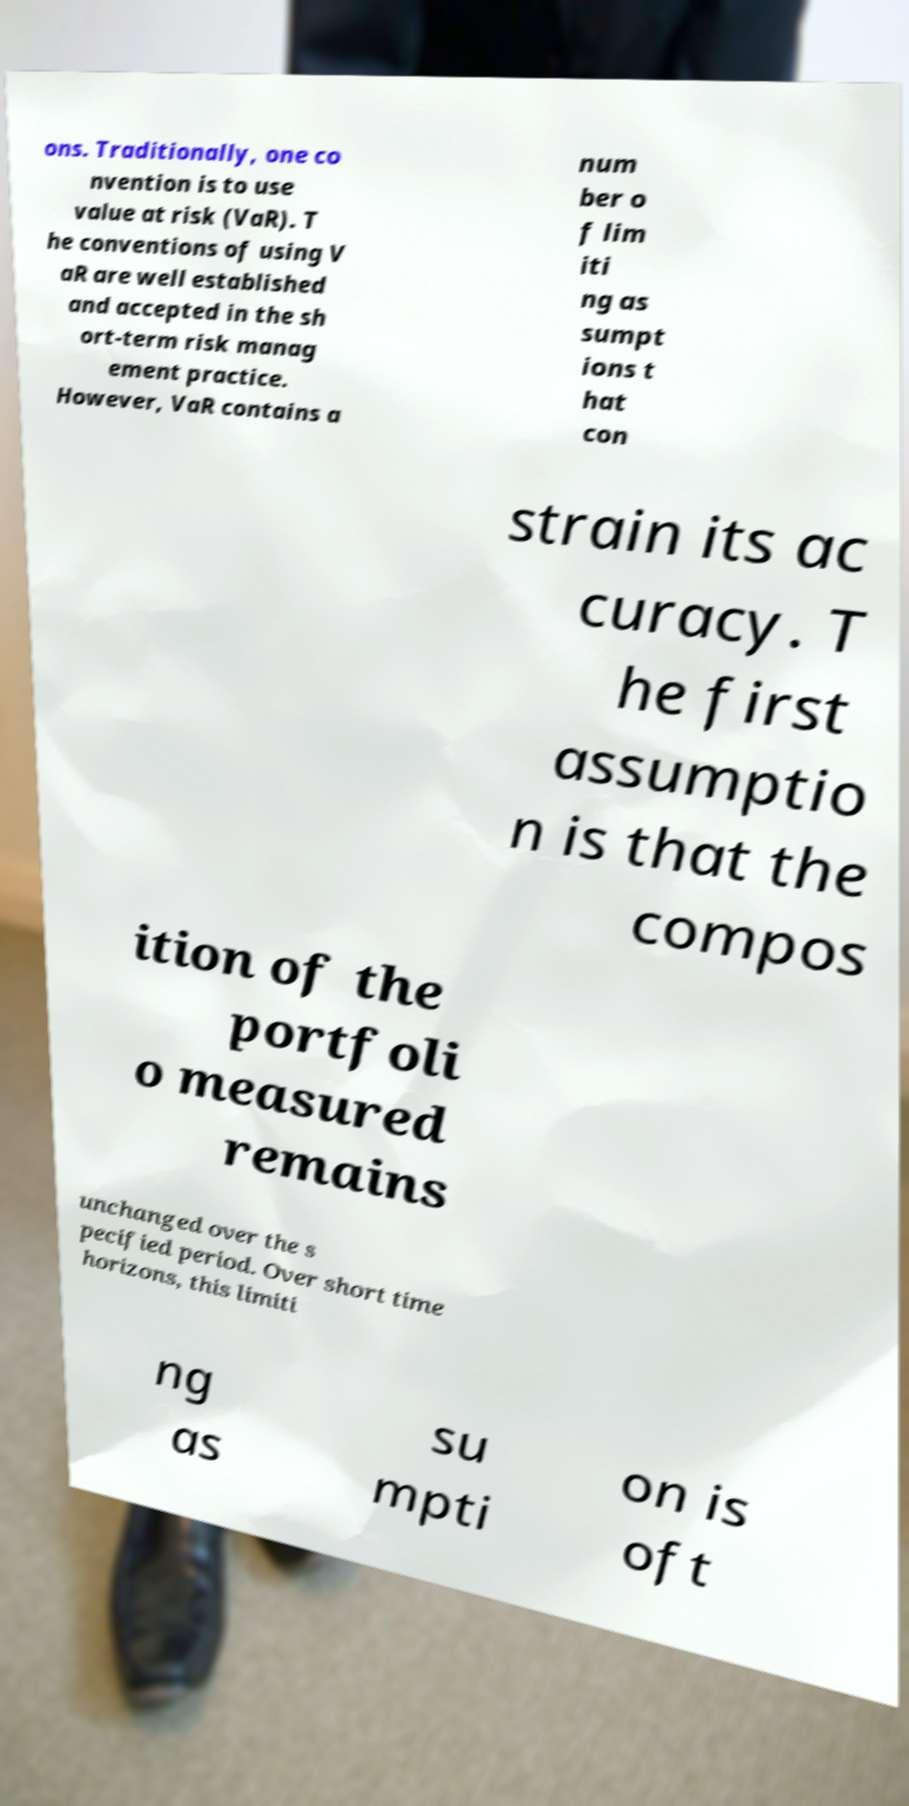Can you accurately transcribe the text from the provided image for me? ons. Traditionally, one co nvention is to use value at risk (VaR). T he conventions of using V aR are well established and accepted in the sh ort-term risk manag ement practice. However, VaR contains a num ber o f lim iti ng as sumpt ions t hat con strain its ac curacy. T he first assumptio n is that the compos ition of the portfoli o measured remains unchanged over the s pecified period. Over short time horizons, this limiti ng as su mpti on is oft 